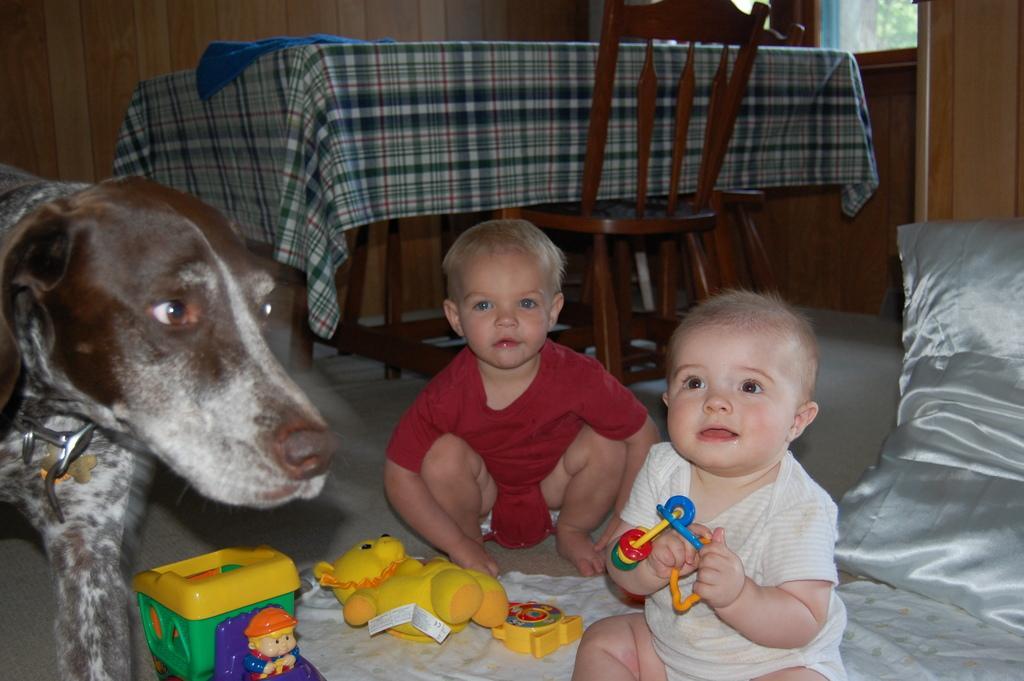Please provide a concise description of this image. In this image I can see two kids, toys, cloth, cushion and a dog on the floor. In the background I can see a table and chairs, window and a wall. This image is taken may be in a room. 